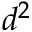<formula> <loc_0><loc_0><loc_500><loc_500>d ^ { 2 }</formula> 